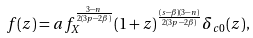Convert formula to latex. <formula><loc_0><loc_0><loc_500><loc_500>f ( z ) = a f _ { X } ^ { \frac { 3 - n } { 2 ( 3 p - 2 \beta ) } } ( 1 + z ) ^ { \frac { ( s - \beta ) ( 3 - n ) } { 2 ( 3 p - 2 \beta ) } } \delta _ { c 0 } ( z ) ,</formula> 